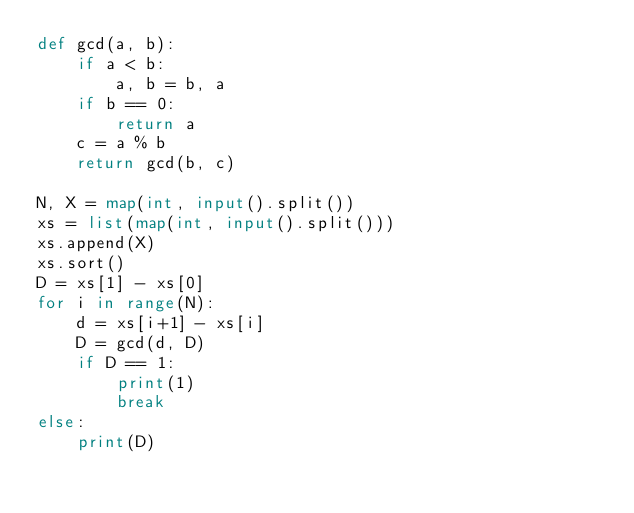Convert code to text. <code><loc_0><loc_0><loc_500><loc_500><_Python_>def gcd(a, b):
    if a < b:
        a, b = b, a
    if b == 0:
        return a
    c = a % b
    return gcd(b, c)

N, X = map(int, input().split())
xs = list(map(int, input().split()))
xs.append(X)
xs.sort()
D = xs[1] - xs[0]
for i in range(N):
    d = xs[i+1] - xs[i]
    D = gcd(d, D)
    if D == 1:
        print(1)
        break
else:
    print(D)
</code> 